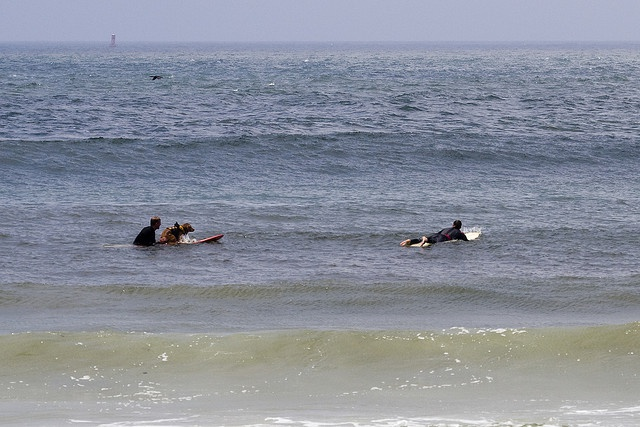Describe the objects in this image and their specific colors. I can see people in darkgray, black, and gray tones, dog in darkgray, black, maroon, and gray tones, people in darkgray, black, and gray tones, surfboard in darkgray, gray, and black tones, and surfboard in darkgray, ivory, tan, and gray tones in this image. 